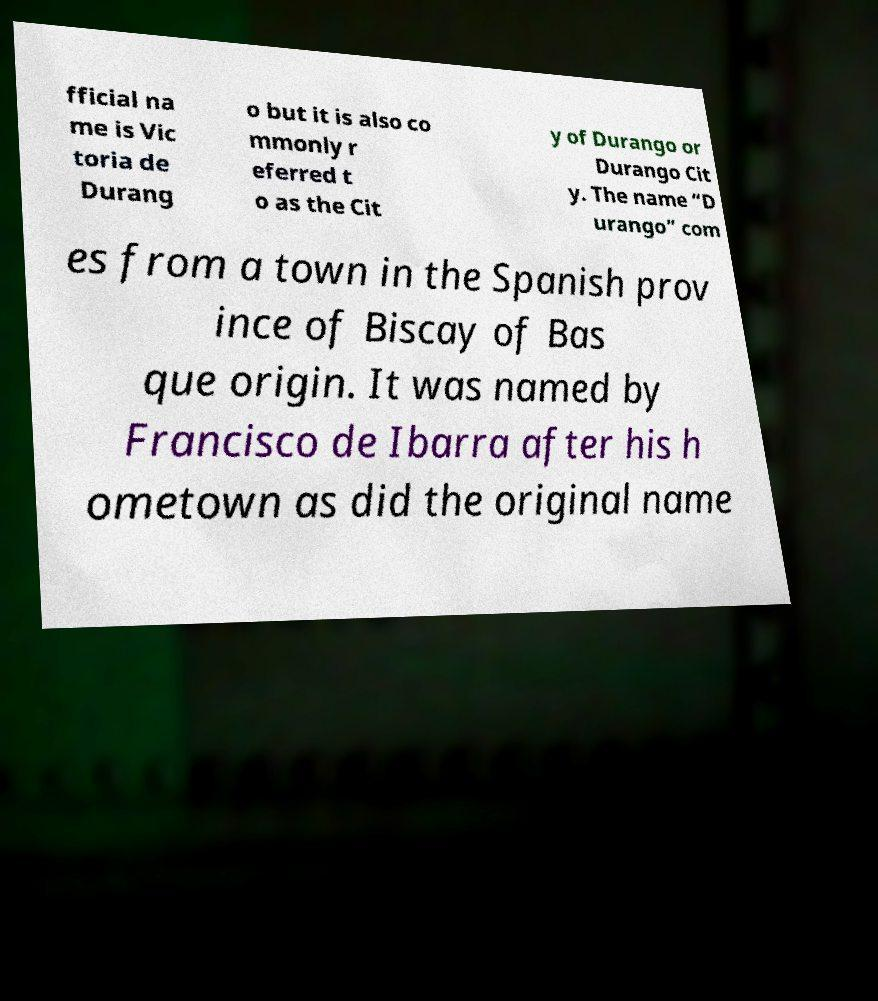What messages or text are displayed in this image? I need them in a readable, typed format. fficial na me is Vic toria de Durang o but it is also co mmonly r eferred t o as the Cit y of Durango or Durango Cit y. The name “D urango” com es from a town in the Spanish prov ince of Biscay of Bas que origin. It was named by Francisco de Ibarra after his h ometown as did the original name 